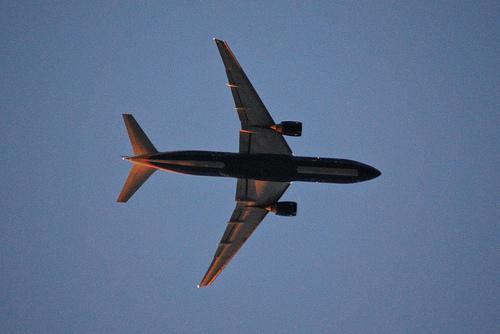How many planes in the image?
Give a very brief answer. 1. 